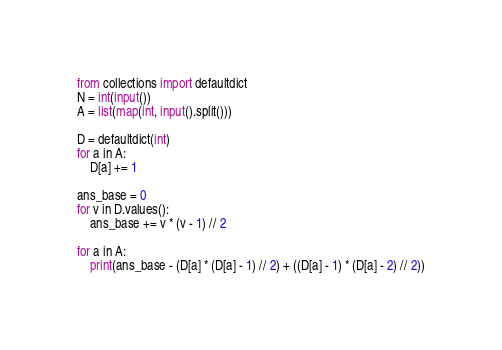<code> <loc_0><loc_0><loc_500><loc_500><_Python_>from collections import defaultdict
N = int(input())
A = list(map(int, input().split()))

D = defaultdict(int)
for a in A:
    D[a] += 1

ans_base = 0
for v in D.values():
    ans_base += v * (v - 1) // 2

for a in A:
    print(ans_base - (D[a] * (D[a] - 1) // 2) + ((D[a] - 1) * (D[a] - 2) // 2))
</code> 